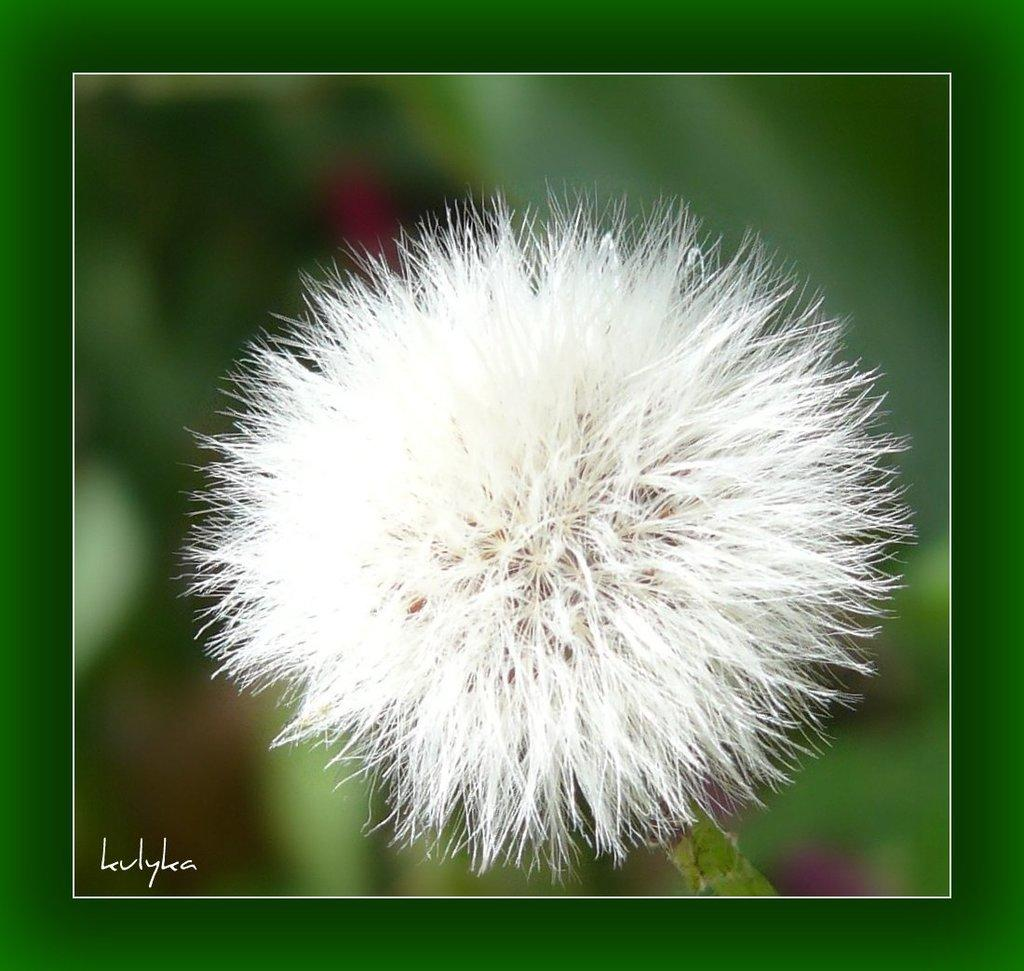What is the main subject of the image? The main subject of the image is a stem with a flower. Can you describe the background of the image? The background of the image is blurry. Is there any additional information or branding present in the image? Yes, there is a watermark in the bottom left corner of the image. How many pigs can be seen running in the background of the image? There are no pigs present in the image; the background is blurry and does not show any animals. 